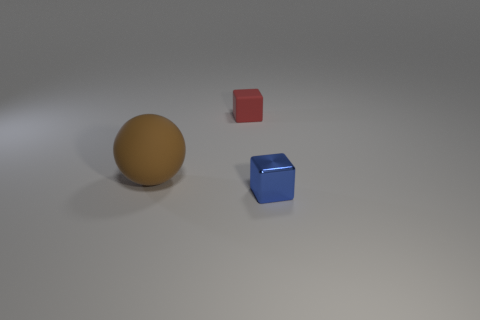Is there any indication of the material these objects are made of? Based on the visual aspects, the brown sphere appears to have a matte surface, which suggests it may be made of a non-reflective material. The red and blue cubes, however, look to have a slight sheen to their surfaces, indicating they could be made of a plastic or painted wood, commonly associated with child's building blocks. What atmosphere does the lighting of the image evoke? The lighting in the image is soft and diffuse, casting gentle shadows beneath the objects and contributing to an overall tranquil and neutral atmosphere. This type of lighting minimizes harsh contrasts, allowing the colors and shapes of the objects to be the central focus without overpowering brightness or darkness. 